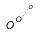Convert formula to latex. <formula><loc_0><loc_0><loc_500><loc_500>o ^ { o ^ { \cdot ^ { \cdot ^ { \cdot ^ { o } } } } }</formula> 